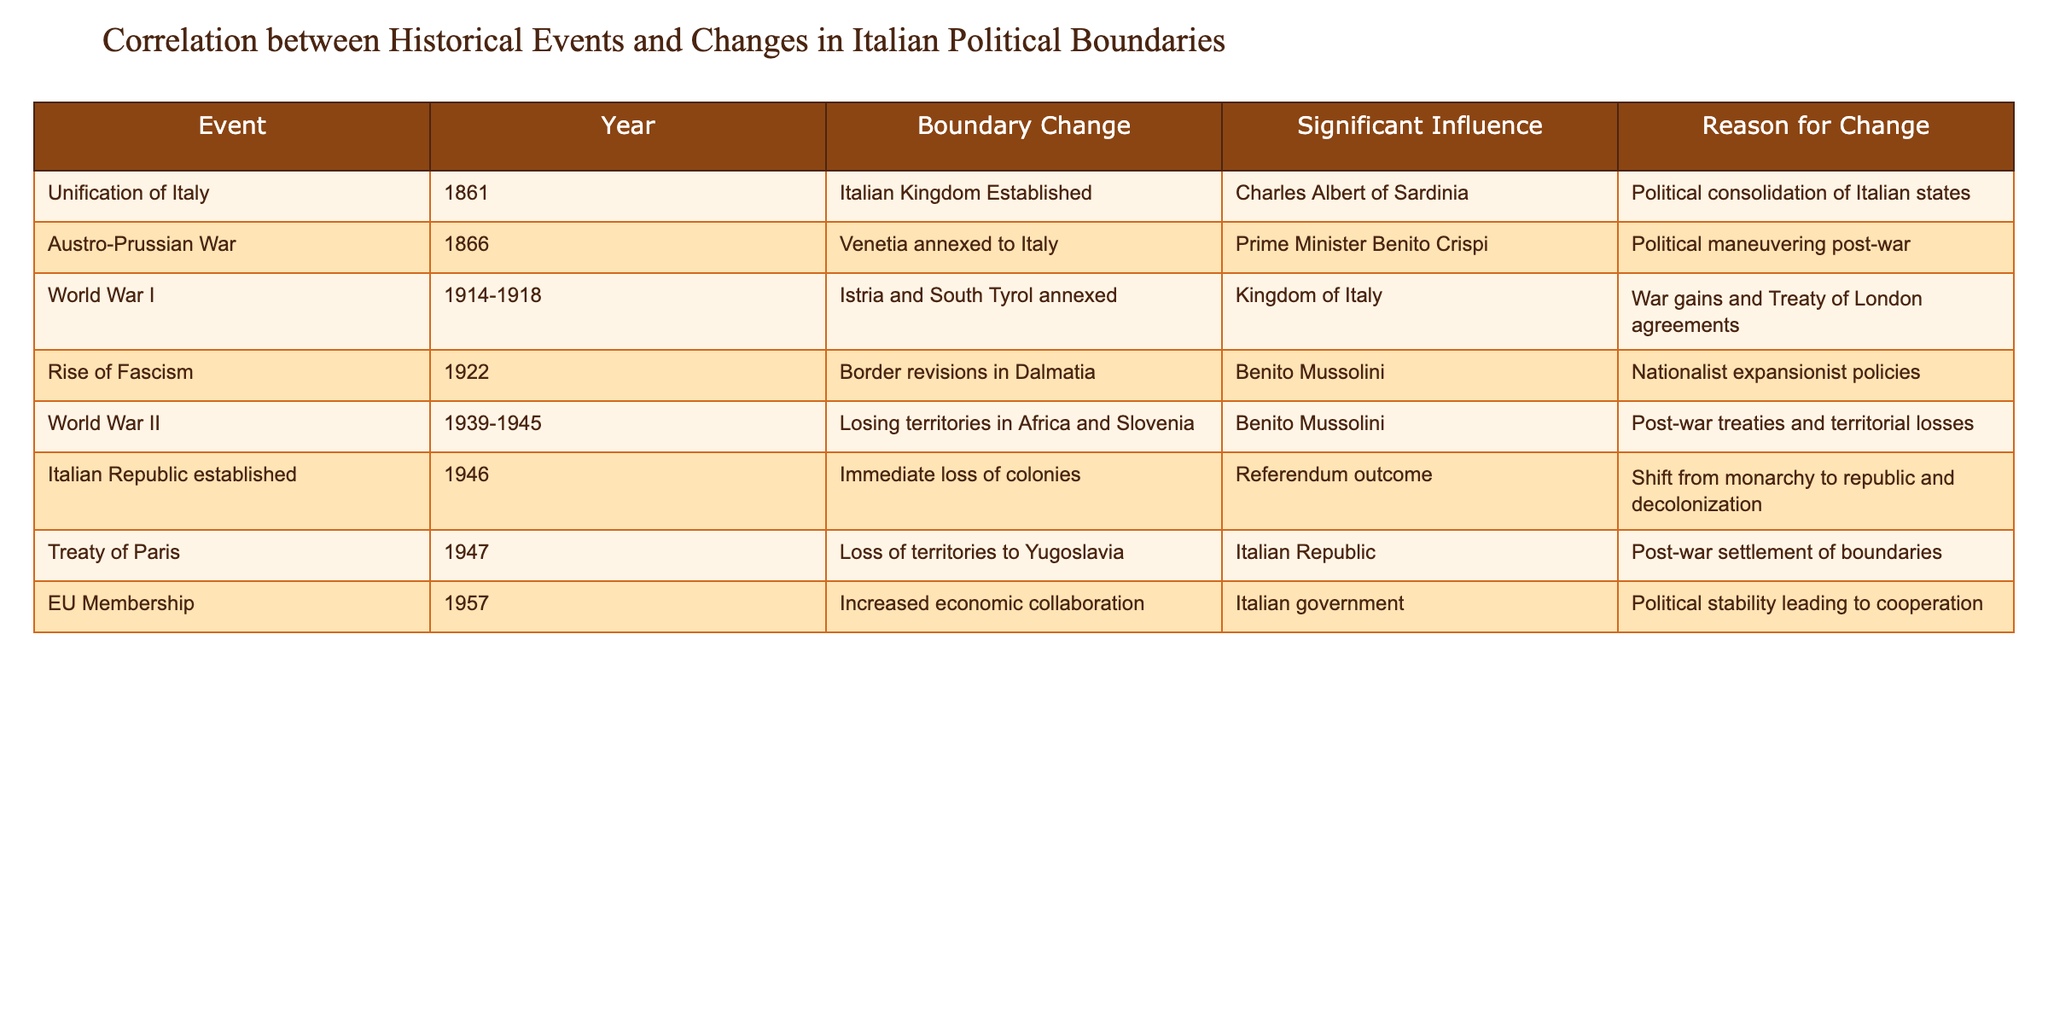What event led to the establishment of the Italian Kingdom? According to the table, the Unification of Italy occurred in 1861, which directly resulted in the establishment of the Italian Kingdom.
Answer: Unification of Italy Which territories were annexed to Italy as a result of World War I? The table reveals that during World War I (1914-1918), Istria and South Tyrol were annexed to Italy due to war gains and Treaty of London agreements.
Answer: Istria and South Tyrol What was the reason for the loss of territories during World War II? The table indicates that Italy lost territories in Africa and Slovenia during World War II due to post-war treaties and territorial losses under Benito Mussolini's rule.
Answer: Post-war treaties and territorial losses Was the Treaty of Paris linked to any loss of territories for Italy? Yes, the table states that the Treaty of Paris in 1947 resulted in a loss of territories to Yugoslavia as part of a post-war settlement of boundaries.
Answer: Yes What change occurred in Italy's political boundaries after the establishment of the Italian Republic in 1946? Following the establishment of the Italian Republic, the table notes an immediate loss of colonies as a result of a referendum outcome signifying a shift from a monarchy to a republic and decolonization.
Answer: Immediate loss of colonies How many significant territorial changes are attributed to the rise of Fascism in 1922? According to the table, there is one significant territorial change listed, which is the border revisions in Dalmatia due to nationalist expansionist policies under Benito Mussolini.
Answer: One significant change What was the political influence behind the annexation of Venetia to Italy? The table states that the Austro-Prussian War in 1866 led to the annexation of Venetia, influenced by Prime Minister Benito Crispi and political maneuvering post-war.
Answer: Prime Minister Benito Crispi Which year did Italy join the European Union, and what was the main effect on political boundaries? The table indicates that Italy joined the European Union in 1957, resulting in increased economic collaboration due to political stability leading to cooperation.
Answer: 1957, increased economic collaboration How does the number of boundary changes related to wars compare to those related to political shifts like the establishment of a republic? From the table, there are four boundary changes related to wars (Austro-Prussian War, World War I, World War II, Treaty of Paris), while there are two related to political shifts (Italian Republic and EU Membership), indicating a greater number associated with wars.
Answer: More boundary changes related to wars 